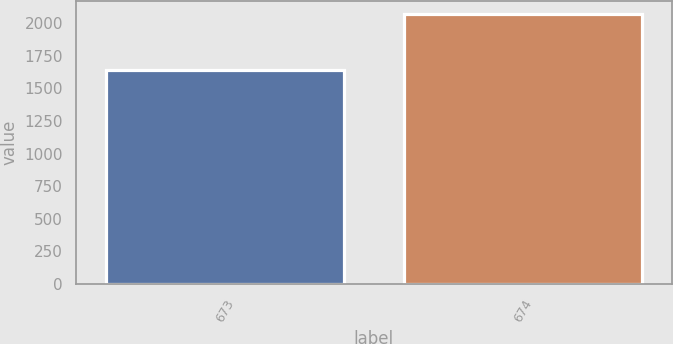<chart> <loc_0><loc_0><loc_500><loc_500><bar_chart><fcel>673<fcel>674<nl><fcel>1644.1<fcel>2067<nl></chart> 